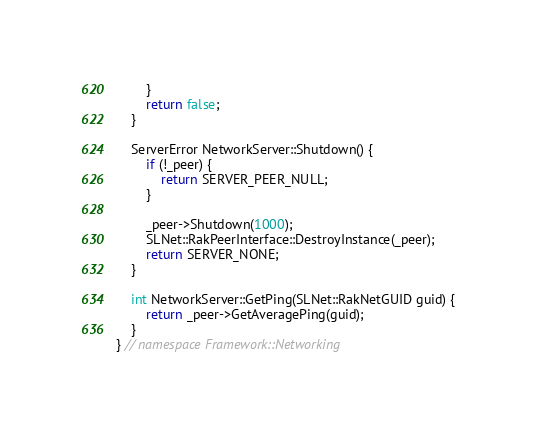<code> <loc_0><loc_0><loc_500><loc_500><_C++_>        }
        return false;
    }

    ServerError NetworkServer::Shutdown() {
        if (!_peer) {
            return SERVER_PEER_NULL;
        }

        _peer->Shutdown(1000);
        SLNet::RakPeerInterface::DestroyInstance(_peer);
        return SERVER_NONE;
    }

    int NetworkServer::GetPing(SLNet::RakNetGUID guid) {
        return _peer->GetAveragePing(guid);
    }
} // namespace Framework::Networking
</code> 